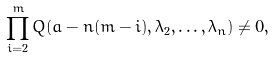Convert formula to latex. <formula><loc_0><loc_0><loc_500><loc_500>\prod _ { i = 2 } ^ { m } Q ( a - n ( m - i ) , \lambda _ { 2 } , \dots , \lambda _ { n } ) \neq 0 ,</formula> 